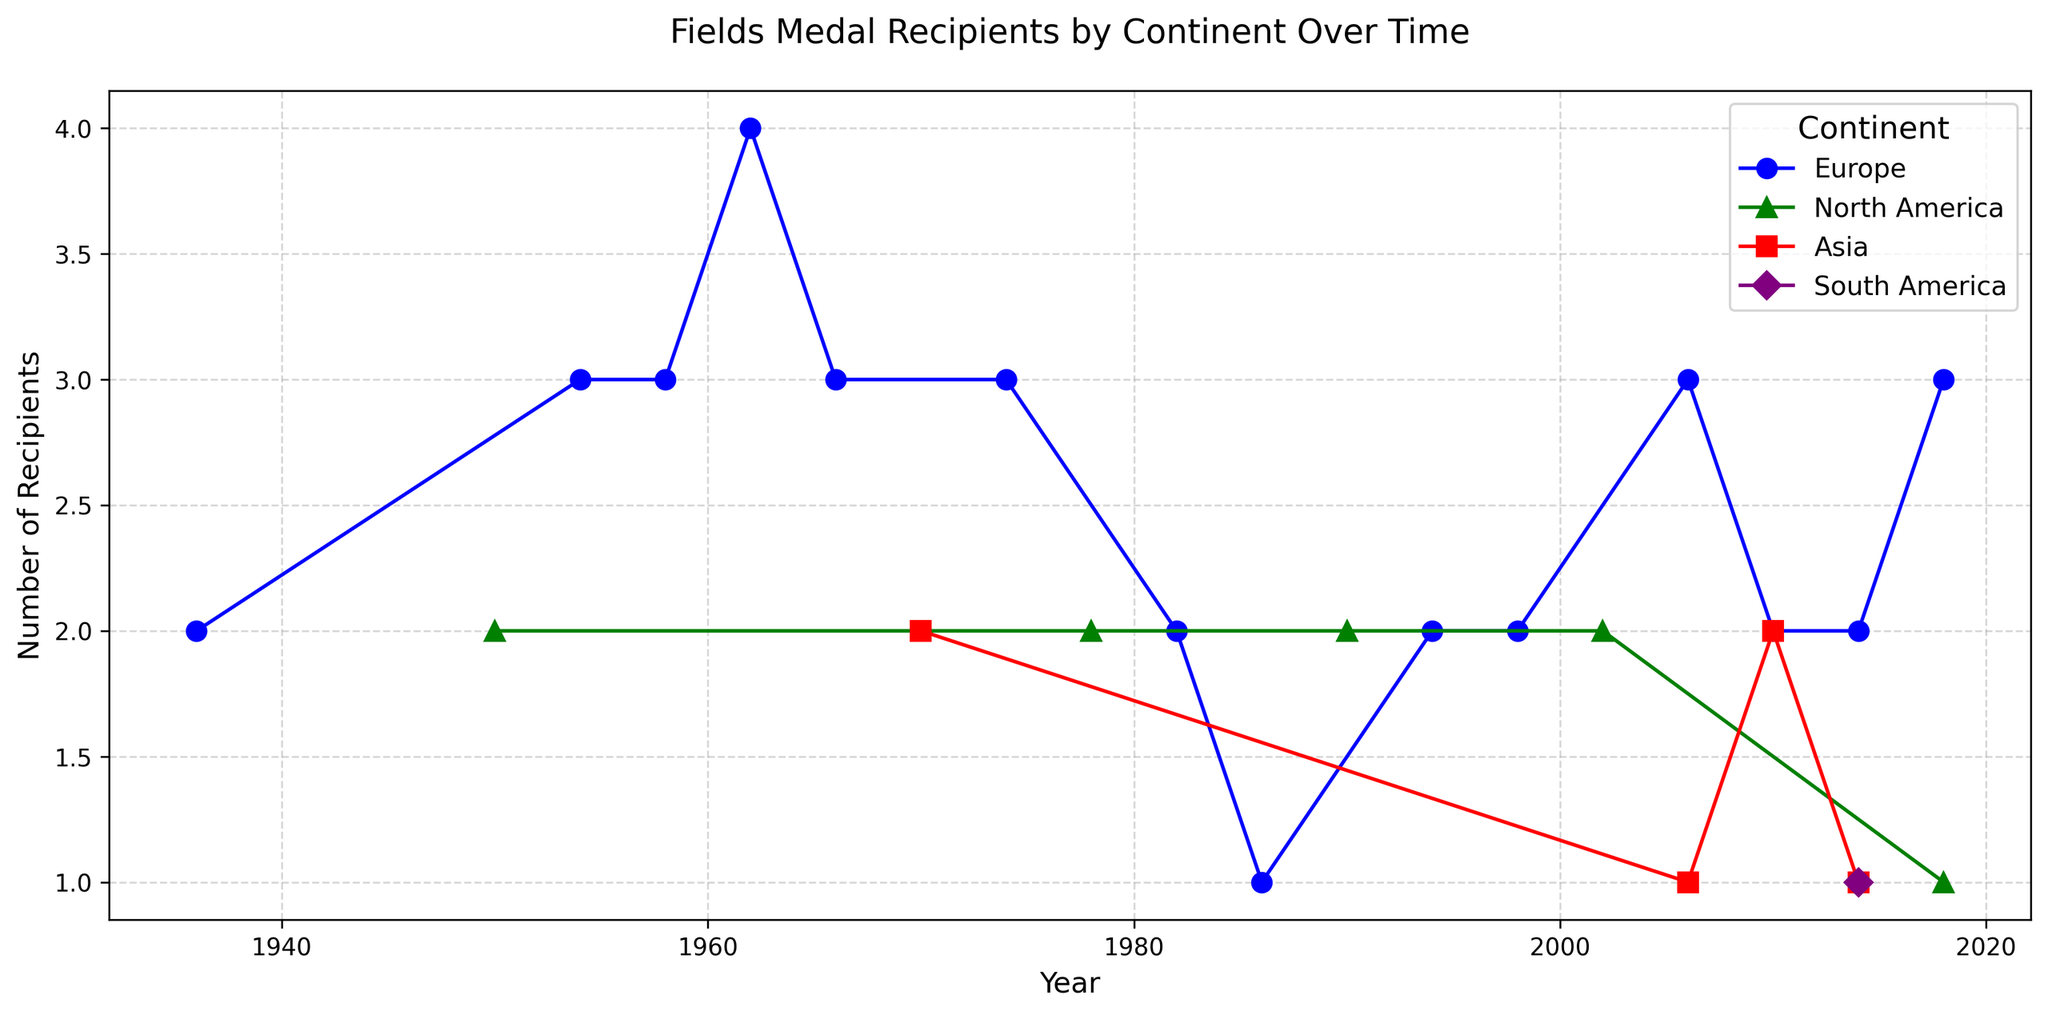What year had the first Fields Medal recipients from Asia? Look at the red markers representing Asia on the plot and find the earliest year. In this case, the first red marker appears in 1970.
Answer: 1970 How many recipients were from Europe in 1962? Check the blue markers for Europe in the year 1962. The y-axis value at this point shows 4 recipients.
Answer: 4 Which continent had Fields Medal recipients in 2014 apart from Europe? Look for markers other than blue in the year 2014. Notice that purple (South America) and red (Asia) also appear in this year.
Answer: South America, Asia What is the difference in the number of recipients between Europe and North America in 1950? Europe had no recipients in 1950, while North America had 2. The difference is 2 - 0 = 2.
Answer: 2 Which continent has the highest number of recipients in a single year, and what is that number? Look at the y-axis values for each marker and find the maximum. The highest value is 4, for Europe in 1962.
Answer: Europe, 4 How many times did Europe have exactly 3 recipients in a single year? Count the number of blue markers positioned at y = 3. This occurs in 1954, 1958, 1966, 1974, 2006, and 2018.
Answer: 6 Compare the total number of recipients from Europe between 1954 and 1986 to North America's total in the same period. For Europe: 3 (1954) + 3 (1958) + 4 (1962) + 3 (1966) + 3 (1974) + 2 (1982) + 1 (1986) = 19. For North America: 2 (1950) + 2 (1978) + 2 (1990) = 6.
Answer: Europe, 19 What was the average number of recipients per year for Asia across all years shown? Asia has recipients in 1970 (2), 2006 (1), 2010 (2), and 2014 (1), so the average is (2 + 1 + 2 + 1) / 4 = 1.5.
Answer: 1.5 During which years did Europe have exactly 2 recipients? Identify blue markers at y = 2, which are in 1982, 1994, 1998, 2010, and 2014.
Answer: 1982, 1994, 1998, 2010, 2014 Was there a year where North America had more recipients than Europe? If so, when? Compare the green and blue markers. North America had more recipients only in 1986 when Europe had 1, and North America had 2.
Answer: 1986 